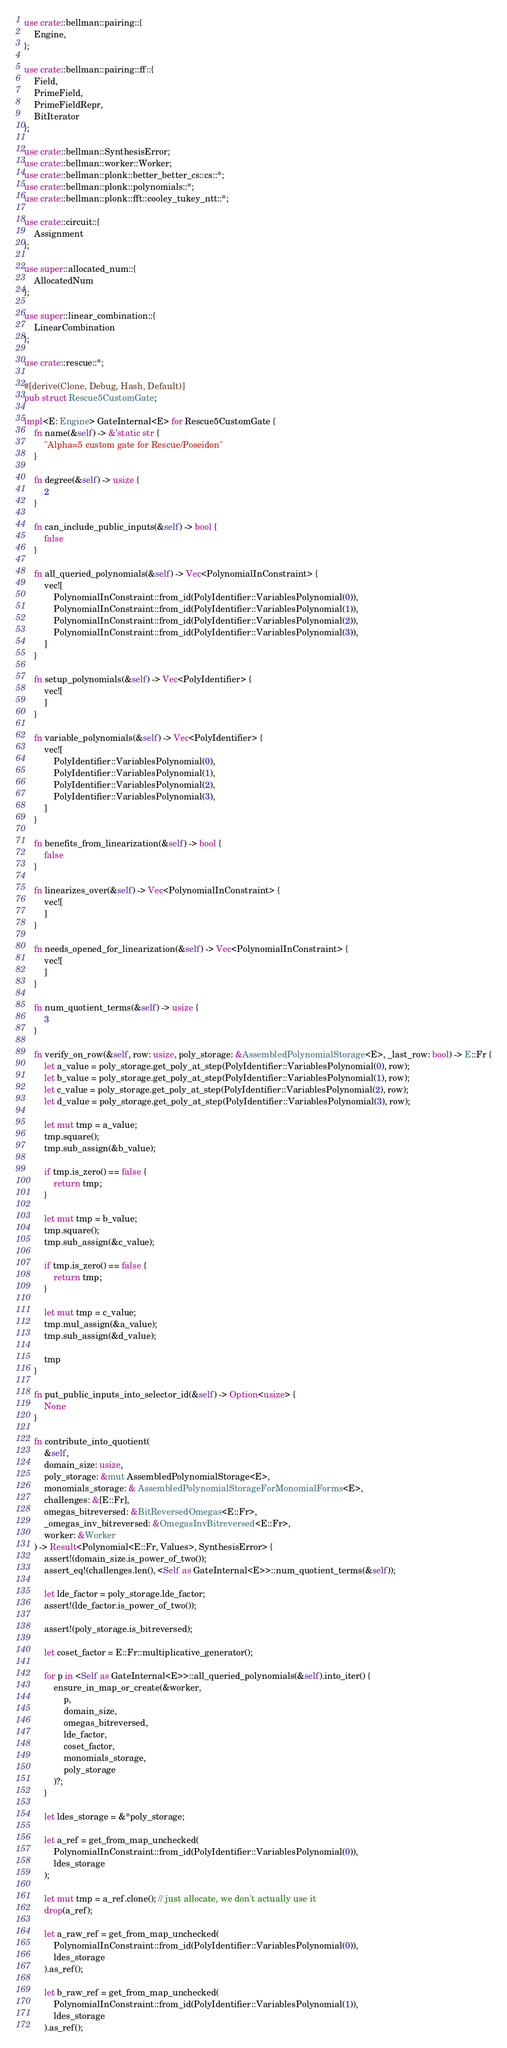Convert code to text. <code><loc_0><loc_0><loc_500><loc_500><_Rust_>use crate::bellman::pairing::{
    Engine,
};

use crate::bellman::pairing::ff::{
    Field,
    PrimeField,
    PrimeFieldRepr,
    BitIterator
};

use crate::bellman::SynthesisError;
use crate::bellman::worker::Worker;
use crate::bellman::plonk::better_better_cs::cs::*;
use crate::bellman::plonk::polynomials::*;
use crate::bellman::plonk::fft::cooley_tukey_ntt::*;

use crate::circuit::{
    Assignment
};

use super::allocated_num::{
    AllocatedNum
};

use super::linear_combination::{
    LinearCombination
};

use crate::rescue::*;

#[derive(Clone, Debug, Hash, Default)]
pub struct Rescue5CustomGate;

impl<E: Engine> GateInternal<E> for Rescue5CustomGate {
    fn name(&self) -> &'static str {
        "Alpha=5 custom gate for Rescue/Poseidon"
    }

    fn degree(&self) -> usize {
        2
    }

    fn can_include_public_inputs(&self) -> bool {
        false
    }

    fn all_queried_polynomials(&self) -> Vec<PolynomialInConstraint> {
        vec![
            PolynomialInConstraint::from_id(PolyIdentifier::VariablesPolynomial(0)),
            PolynomialInConstraint::from_id(PolyIdentifier::VariablesPolynomial(1)),
            PolynomialInConstraint::from_id(PolyIdentifier::VariablesPolynomial(2)),
            PolynomialInConstraint::from_id(PolyIdentifier::VariablesPolynomial(3)),
        ]
    }

    fn setup_polynomials(&self) -> Vec<PolyIdentifier> {
        vec![
        ]
    }

    fn variable_polynomials(&self) -> Vec<PolyIdentifier> {
        vec![
            PolyIdentifier::VariablesPolynomial(0),
            PolyIdentifier::VariablesPolynomial(1),
            PolyIdentifier::VariablesPolynomial(2),
            PolyIdentifier::VariablesPolynomial(3),
        ]
    }

    fn benefits_from_linearization(&self) -> bool {
        false
    }

    fn linearizes_over(&self) -> Vec<PolynomialInConstraint> {
        vec![
        ]
    }

    fn needs_opened_for_linearization(&self) -> Vec<PolynomialInConstraint> {
        vec![
        ]
    }

    fn num_quotient_terms(&self) -> usize {
        3
    }

    fn verify_on_row(&self, row: usize, poly_storage: &AssembledPolynomialStorage<E>, _last_row: bool) -> E::Fr {
        let a_value = poly_storage.get_poly_at_step(PolyIdentifier::VariablesPolynomial(0), row);
        let b_value = poly_storage.get_poly_at_step(PolyIdentifier::VariablesPolynomial(1), row);
        let c_value = poly_storage.get_poly_at_step(PolyIdentifier::VariablesPolynomial(2), row);
        let d_value = poly_storage.get_poly_at_step(PolyIdentifier::VariablesPolynomial(3), row);
        
        let mut tmp = a_value;
        tmp.square();
        tmp.sub_assign(&b_value);

        if tmp.is_zero() == false {
            return tmp;
        }

        let mut tmp = b_value;
        tmp.square();
        tmp.sub_assign(&c_value);

        if tmp.is_zero() == false {
            return tmp;
        }

        let mut tmp = c_value;
        tmp.mul_assign(&a_value);
        tmp.sub_assign(&d_value);

        tmp
    }

    fn put_public_inputs_into_selector_id(&self) -> Option<usize> {
        None
    }

    fn contribute_into_quotient(
        &self, 
        domain_size: usize,
        poly_storage: &mut AssembledPolynomialStorage<E>,
        monomials_storage: & AssembledPolynomialStorageForMonomialForms<E>,
        challenges: &[E::Fr],
        omegas_bitreversed: &BitReversedOmegas<E::Fr>,
        _omegas_inv_bitreversed: &OmegasInvBitreversed<E::Fr>,
        worker: &Worker
    ) -> Result<Polynomial<E::Fr, Values>, SynthesisError> {
        assert!(domain_size.is_power_of_two());
        assert_eq!(challenges.len(), <Self as GateInternal<E>>::num_quotient_terms(&self));

        let lde_factor = poly_storage.lde_factor;
        assert!(lde_factor.is_power_of_two());

        assert!(poly_storage.is_bitreversed);

        let coset_factor = E::Fr::multiplicative_generator();
       
        for p in <Self as GateInternal<E>>::all_queried_polynomials(&self).into_iter() {
            ensure_in_map_or_create(&worker, 
                p, 
                domain_size, 
                omegas_bitreversed, 
                lde_factor, 
                coset_factor, 
                monomials_storage, 
                poly_storage
            )?;
        }

        let ldes_storage = &*poly_storage;

        let a_ref = get_from_map_unchecked(
            PolynomialInConstraint::from_id(PolyIdentifier::VariablesPolynomial(0)),
            ldes_storage
        );

        let mut tmp = a_ref.clone(); // just allocate, we don't actually use it
        drop(a_ref);

        let a_raw_ref = get_from_map_unchecked(
            PolynomialInConstraint::from_id(PolyIdentifier::VariablesPolynomial(0)),
            ldes_storage
        ).as_ref();

        let b_raw_ref = get_from_map_unchecked(
            PolynomialInConstraint::from_id(PolyIdentifier::VariablesPolynomial(1)),
            ldes_storage
        ).as_ref();
</code> 